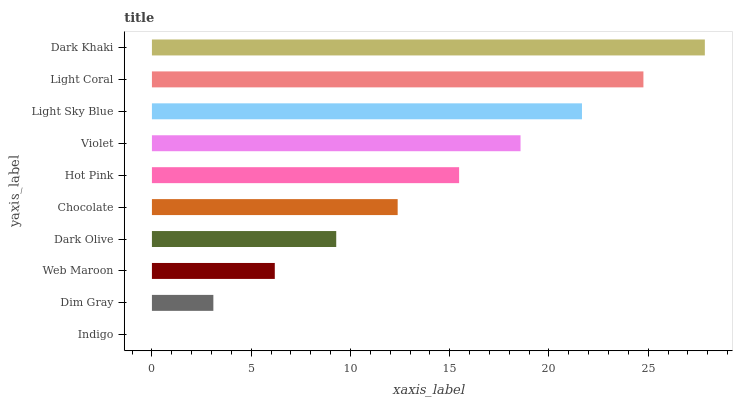Is Indigo the minimum?
Answer yes or no. Yes. Is Dark Khaki the maximum?
Answer yes or no. Yes. Is Dim Gray the minimum?
Answer yes or no. No. Is Dim Gray the maximum?
Answer yes or no. No. Is Dim Gray greater than Indigo?
Answer yes or no. Yes. Is Indigo less than Dim Gray?
Answer yes or no. Yes. Is Indigo greater than Dim Gray?
Answer yes or no. No. Is Dim Gray less than Indigo?
Answer yes or no. No. Is Hot Pink the high median?
Answer yes or no. Yes. Is Chocolate the low median?
Answer yes or no. Yes. Is Light Sky Blue the high median?
Answer yes or no. No. Is Dark Olive the low median?
Answer yes or no. No. 